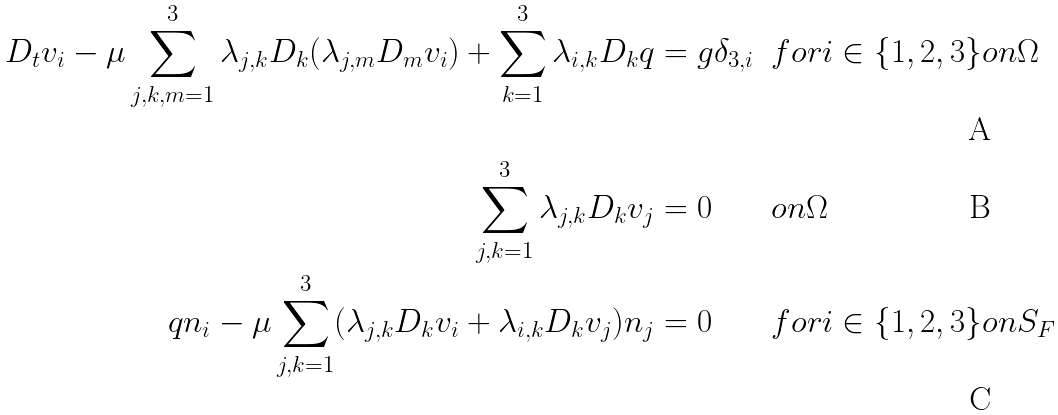Convert formula to latex. <formula><loc_0><loc_0><loc_500><loc_500>D _ { t } v _ { i } - \mu \sum _ { j , k , m = 1 } ^ { 3 } \lambda _ { j , k } D _ { k } ( \lambda _ { j , m } D _ { m } v _ { i } ) + \sum _ { k = 1 } ^ { 3 } \lambda _ { i , k } D _ { k } q & = g \delta _ { 3 , i } & & f o r i \in \{ 1 , 2 , 3 \} o n \Omega \\ \sum _ { j , k = 1 } ^ { 3 } \lambda _ { j , k } D _ { k } v _ { j } & = 0 & & o n \Omega \\ q n _ { i } - \mu \sum _ { j , k = 1 } ^ { 3 } ( \lambda _ { j , k } D _ { k } v _ { i } + \lambda _ { i , k } D _ { k } v _ { j } ) n _ { j } & = 0 & & f o r i \in \{ 1 , 2 , 3 \} o n S _ { F }</formula> 